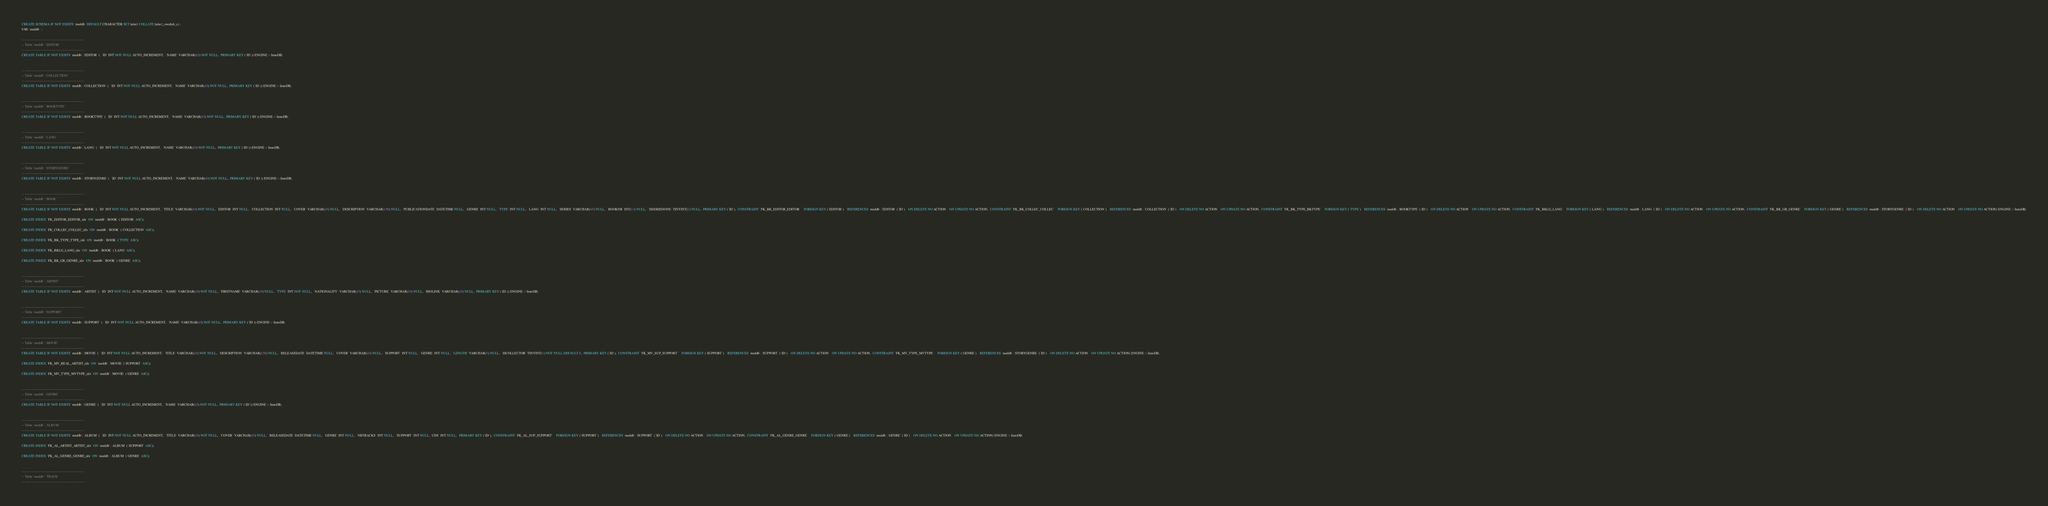<code> <loc_0><loc_0><loc_500><loc_500><_SQL_>CREATE SCHEMA IF NOT EXISTS `meddb` DEFAULT CHARACTER SET latin1 COLLATE latin1_swedish_ci ;
USE `meddb` ;

-- -----------------------------------------------------
-- Table `meddb`.`EDITOR`
-- -----------------------------------------------------
CREATE TABLE IF NOT EXISTS `meddb`.`EDITOR` (  `ID` INT NOT NULL AUTO_INCREMENT,  `NAME` VARCHAR(45) NOT NULL,  PRIMARY KEY (`ID`)) ENGINE = InnoDB;


-- -----------------------------------------------------
-- Table `meddb`.`COLLECTION`
-- -----------------------------------------------------
CREATE TABLE IF NOT EXISTS `meddb`.`COLLECTION` (  `ID` INT NOT NULL AUTO_INCREMENT,  `NAME` VARCHAR(45) NOT NULL,  PRIMARY KEY (`ID`)) ENGINE = InnoDB;


-- -----------------------------------------------------
-- Table `meddb`.`BOOKTYPE`
-- -----------------------------------------------------
CREATE TABLE IF NOT EXISTS `meddb`.`BOOKTYPE` (  `ID` INT NOT NULL AUTO_INCREMENT,  `NAME` VARCHAR(45) NOT NULL,  PRIMARY KEY (`ID`)) ENGINE = InnoDB;


-- -----------------------------------------------------
-- Table `meddb`.`LANG`
-- -----------------------------------------------------
CREATE TABLE IF NOT EXISTS `meddb`.`LANG` (  `ID` INT NOT NULL AUTO_INCREMENT,  `NAME` VARCHAR(45) NOT NULL,  PRIMARY KEY (`ID`)) ENGINE = InnoDB;


-- -----------------------------------------------------
-- Table `meddb`.`STORYGENRE`
-- -----------------------------------------------------
CREATE TABLE IF NOT EXISTS `meddb`.`STORYGENRE` (  `ID` INT NOT NULL AUTO_INCREMENT,  `NAME` VARCHAR(45) NOT NULL,  PRIMARY KEY (`ID`)) ENGINE = InnoDB;


-- -----------------------------------------------------
-- Table `meddb`.`BOOK`
-- -----------------------------------------------------
CREATE TABLE IF NOT EXISTS `meddb`.`BOOK` (  `ID` INT NOT NULL AUTO_INCREMENT,  `TITLE` VARCHAR(45) NOT NULL,  `EDITOR` INT NULL,  `COLLECTION` INT NULL,  `COVER` VARCHAR(45) NULL,  `DESCRIPTION` VARCHAR(150) NULL,  `PUBLICATIONDATE` DATETIME NULL,  `GENRE` INT NULL,  `TYPE` INT NULL,  `LANG` INT NULL,  `SERIES` VARCHAR(45) NULL,  `BOOKNB` INT(11) NULL,  `ISSERIEDONE` TINYINT(1) NULL,  PRIMARY KEY (`ID`),  CONSTRAINT `FK_BK_EDITOR_EDITOR`    FOREIGN KEY (`EDITOR`)    REFERENCES `meddb`.`EDITOR` (`ID`)    ON DELETE NO ACTION    ON UPDATE NO ACTION,  CONSTRAINT `FK_BK_COLLEC_COLLEC`    FOREIGN KEY (`COLLECTION`)    REFERENCES `meddb`.`COLLECTION` (`ID`)    ON DELETE NO ACTION    ON UPDATE NO ACTION,  CONSTRAINT `FK_BK_TYPE_BKTYPE`    FOREIGN KEY (`TYPE`)    REFERENCES `meddb`.`BOOKTYPE` (`ID`)    ON DELETE NO ACTION    ON UPDATE NO ACTION,  CONSTRAINT `FK_BKLG_LANG`    FOREIGN KEY (`LANG`)    REFERENCES `meddb`.`LANG` (`ID`)    ON DELETE NO ACTION    ON UPDATE NO ACTION,  CONSTRAINT `FK_BK_GR_GENRE`    FOREIGN KEY (`GENRE`)    REFERENCES `meddb`.`STORYGENRE` (`ID`)    ON DELETE NO ACTION    ON UPDATE NO ACTION) ENGINE = InnoDB;

CREATE INDEX `FK_EDITOR_EDITOR_idx` ON `meddb`.`BOOK` (`EDITOR` ASC);

CREATE INDEX `FK_COLLEC_COLLEC_idx` ON `meddb`.`BOOK` (`COLLECTION` ASC);

CREATE INDEX `FK_BK_TYPE_TYPE_idx` ON `meddb`.`BOOK` (`TYPE` ASC);

CREATE INDEX `FK_BKLG_LANG_idx` ON `meddb`.`BOOK` (`LANG` ASC);

CREATE INDEX `FK_BK_GR_GENRE_idx` ON `meddb`.`BOOK` (`GENRE` ASC);


-- -----------------------------------------------------
-- Table `meddb`.`ARTIST`
-- -----------------------------------------------------
CREATE TABLE IF NOT EXISTS `meddb`.`ARTIST` (  `ID` INT NOT NULL AUTO_INCREMENT,  `NAME` VARCHAR(45) NOT NULL,  `FIRSTNAME` VARCHAR(45) NULL,  `TYPE` INT NOT NULL,  `NATIONALITY` VARCHAR(45) NULL,  `PICTURE` VARCHAR(45) NULL,  `BIOLINK` VARCHAR(45) NULL,  PRIMARY KEY (`ID`)) ENGINE = InnoDB;


-- -----------------------------------------------------
-- Table `meddb`.`SUPPORT`
-- -----------------------------------------------------
CREATE TABLE IF NOT EXISTS `meddb`.`SUPPORT` (  `ID` INT NOT NULL AUTO_INCREMENT,  `NAME` VARCHAR(45) NOT NULL,  PRIMARY KEY (`ID`)) ENGINE = InnoDB;


-- -----------------------------------------------------
-- Table `meddb`.`MOVIE`
-- -----------------------------------------------------
CREATE TABLE IF NOT EXISTS `meddb`.`MOVIE` (  `ID` INT NOT NULL AUTO_INCREMENT,  `TITLE` VARCHAR(45) NOT NULL,  `DESCRIPTION` VARCHAR(150) NULL,  `RELEASEDATE` DATETIME NULL,  `COVER` VARCHAR(45) NULL,  `SUPPORT` INT NULL,  `GENRE` INT NULL,  `LENGTH` VARCHAR(5) NULL,  `ISCOLLECTOR` TINYINT(1) NOT NULL DEFAULT 0,  PRIMARY KEY (`ID`),  CONSTRAINT `FK_MV_SUP_SUPPORT`    FOREIGN KEY (`SUPPORT`)    REFERENCES `meddb`.`SUPPORT` (`ID`)    ON DELETE NO ACTION    ON UPDATE NO ACTION,  CONSTRAINT `FK_MV_TYPE_MVTYPE`    FOREIGN KEY (`GENRE`)    REFERENCES `meddb`.`STORYGENRE` (`ID`)    ON DELETE NO ACTION    ON UPDATE NO ACTION) ENGINE = InnoDB;

CREATE INDEX `FK_MV_REAL_ARTIST_idx` ON `meddb`.`MOVIE` (`SUPPORT` ASC);

CREATE INDEX `FK_MV_TYPE_MVTYPE_idx` ON `meddb`.`MOVIE` (`GENRE` ASC);


-- -----------------------------------------------------
-- Table `meddb`.`GENRE`
-- -----------------------------------------------------
CREATE TABLE IF NOT EXISTS `meddb`.`GENRE` (  `ID` INT NOT NULL AUTO_INCREMENT,  `NAME` VARCHAR(45) NOT NULL,  PRIMARY KEY (`ID`)) ENGINE = InnoDB;


-- -----------------------------------------------------
-- Table `meddb`.`ALBUM`
-- -----------------------------------------------------
CREATE TABLE IF NOT EXISTS `meddb`.`ALBUM` (  `ID` INT NOT NULL AUTO_INCREMENT,  `TITLE` VARCHAR(45) NOT NULL,  `COVER` VARCHAR(45) NULL,  `RELEASEDATE` DATETIME NULL,  `GENRE` INT NULL,  `NBTRACKS` INT NULL,  `SUPPORT` INT NULL, `CDS` INT NULL,   PRIMARY KEY (`ID`),  CONSTRAINT `FK_AL_SUP_SUPPORT`    FOREIGN KEY (`SUPPORT`)    REFERENCES `meddb`.`SUPPORT` (`ID`)    ON DELETE NO ACTION    ON UPDATE NO ACTION,  CONSTRAINT `FK_AL_GENRE_GENRE`    FOREIGN KEY (`GENRE`)    REFERENCES `meddb`.`GENRE` (`ID`)    ON DELETE NO ACTION    ON UPDATE NO ACTION) ENGINE = InnoDB;

CREATE INDEX `FK_AL_ARTIST_ARTIST_idx` ON `meddb`.`ALBUM` (`SUPPORT` ASC);

CREATE INDEX `FK_AL_GENRE_GENRE_idx` ON `meddb`.`ALBUM` (`GENRE` ASC);


-- -----------------------------------------------------
-- Table `meddb`.`TRACK`
-- -----------------------------------------------------</code> 